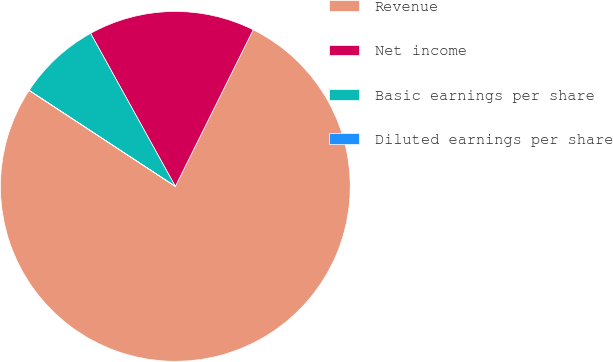Convert chart to OTSL. <chart><loc_0><loc_0><loc_500><loc_500><pie_chart><fcel>Revenue<fcel>Net income<fcel>Basic earnings per share<fcel>Diluted earnings per share<nl><fcel>76.9%<fcel>15.39%<fcel>7.7%<fcel>0.01%<nl></chart> 